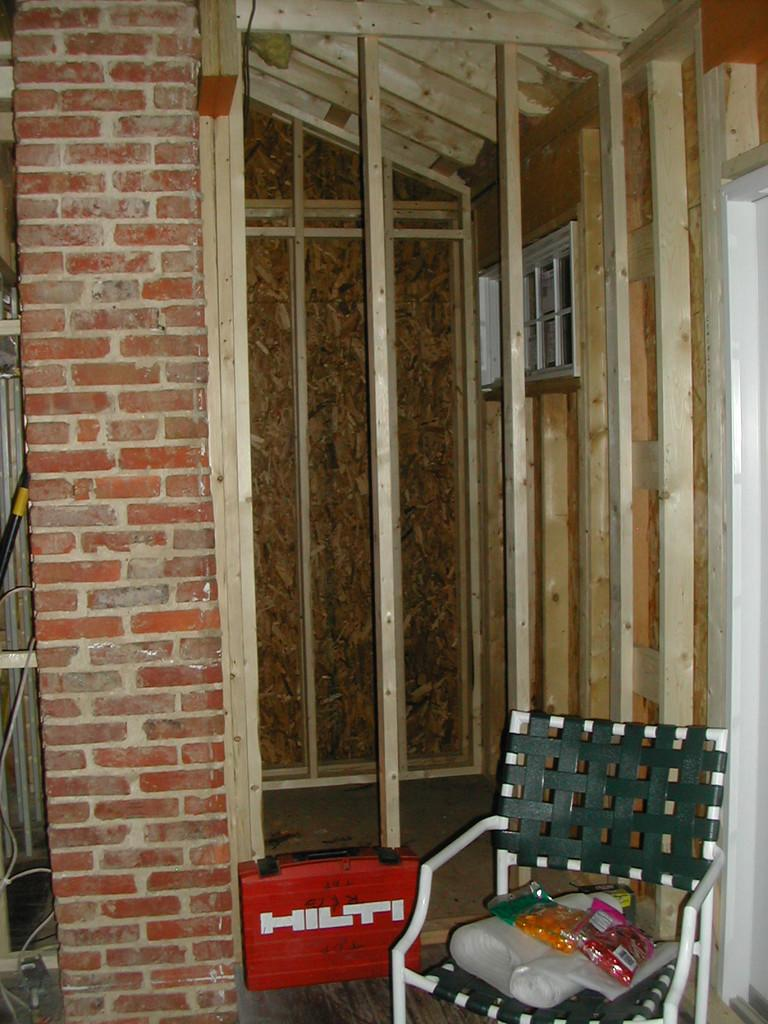What is on the chair in the image? There are things on the chair in the image. What is located near the chair? There is a box beside the chair. What can be seen in the background of the image? Wooden sticks are visible in the background of the image. How many potatoes are on the chair in the image? There is no mention of potatoes in the image; the facts only mention "things" on the chair. What type of regret is depicted in the image? There is no depiction of regret in the image; it only features a chair, a box, and wooden sticks in the background. 